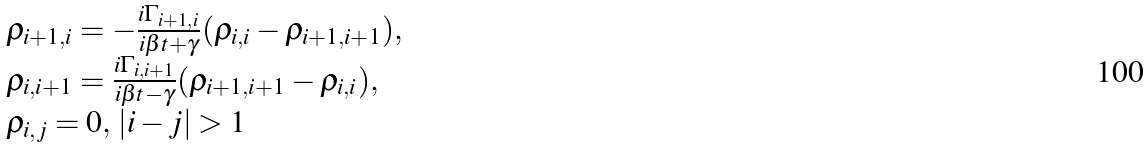<formula> <loc_0><loc_0><loc_500><loc_500>\begin{array} { l } \rho _ { i + 1 , i } = - \frac { i \Gamma _ { i + 1 , i } } { i \beta t + \gamma } ( \rho _ { i , i } - \rho _ { i + 1 , i + 1 } ) , \\ \rho _ { i , i + 1 } = \frac { i \Gamma _ { i , i + 1 } } { i \beta t - \gamma } ( \rho _ { i + 1 , i + 1 } - \rho _ { i , i } ) , \\ \rho _ { i , j } = 0 , \, | i - j | > 1 \end{array}</formula> 